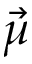Convert formula to latex. <formula><loc_0><loc_0><loc_500><loc_500>\vec { \mu }</formula> 